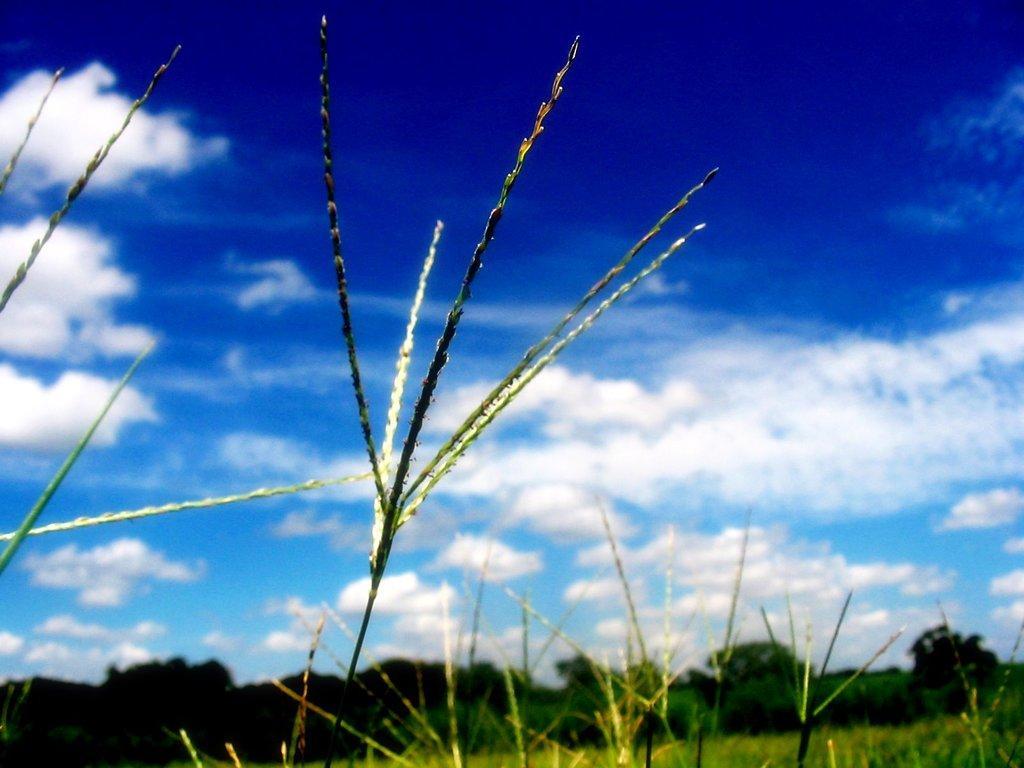What type of vegetation is visible in the image? There is grass in the image. What other natural elements can be seen in the image? There are trees in the image. What is visible in the background of the image? The sky is visible in the image. What can be seen in the sky in the image? There are clouds in the sky. Where is the skate located in the image? There is no skate present in the image. Can you see any cobwebs in the image? There are no cobwebs visible in the image. 